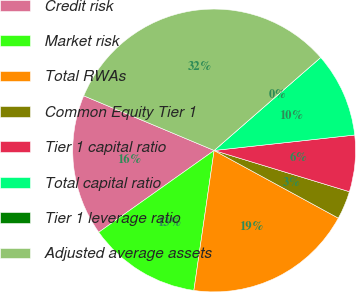Convert chart. <chart><loc_0><loc_0><loc_500><loc_500><pie_chart><fcel>Credit risk<fcel>Market risk<fcel>Total RWAs<fcel>Common Equity Tier 1<fcel>Tier 1 capital ratio<fcel>Total capital ratio<fcel>Tier 1 leverage ratio<fcel>Adjusted average assets<nl><fcel>16.13%<fcel>12.9%<fcel>19.35%<fcel>3.23%<fcel>6.45%<fcel>9.68%<fcel>0.0%<fcel>32.26%<nl></chart> 